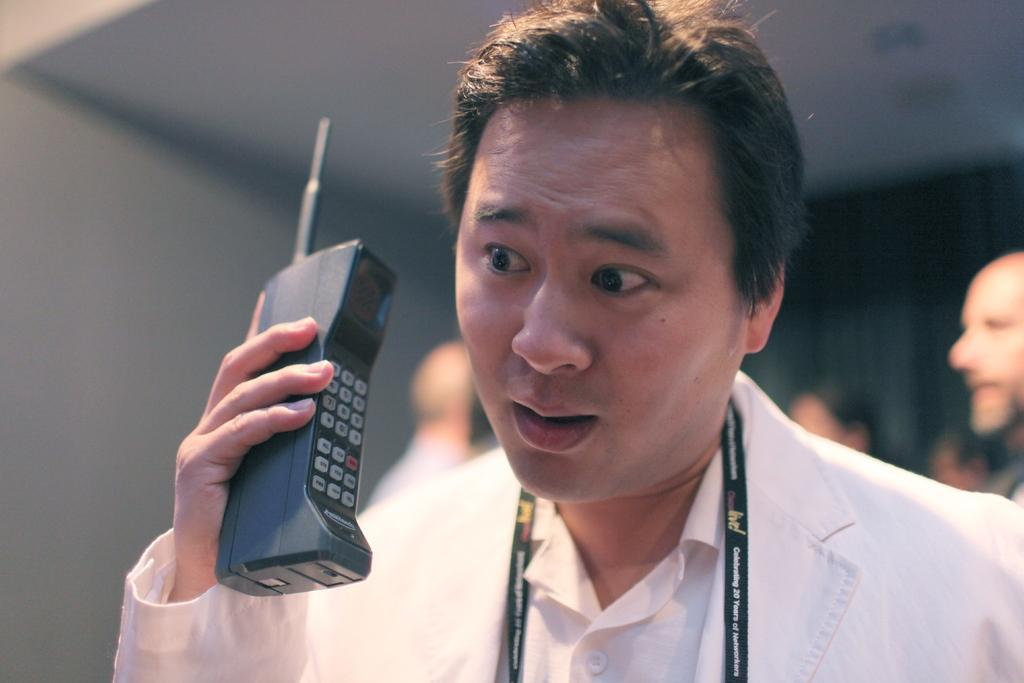Can you describe this image briefly? In this image, we can see a person wearing clothes and holding a phone with his hand. In the background, image is blurred. 